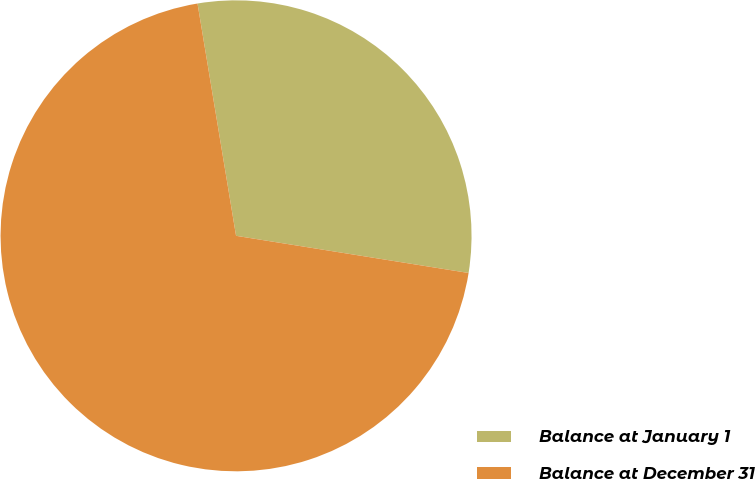Convert chart. <chart><loc_0><loc_0><loc_500><loc_500><pie_chart><fcel>Balance at January 1<fcel>Balance at December 31<nl><fcel>30.14%<fcel>69.86%<nl></chart> 